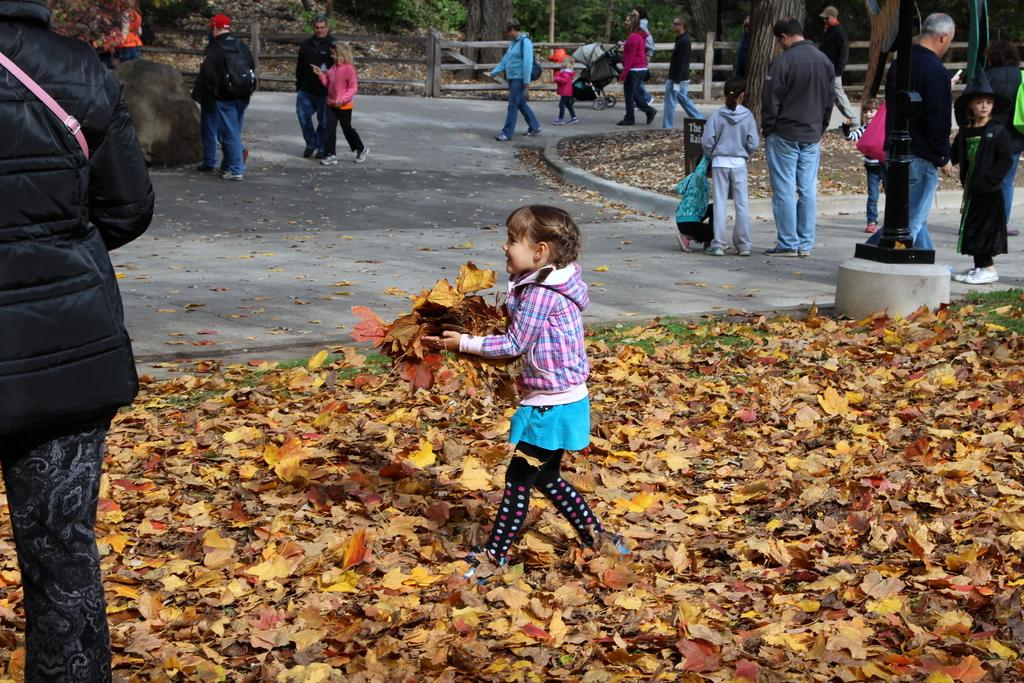What are the people in the image doing? There are people standing and walking in the image. What is the kid holding in the image? The kid is holding leaves in the image. What can be seen at the bottom of the image? There are leaves at the bottom of the image. What is visible in the background of the image? There are trees visible in the background of the image. Is it nighttime in the image, and can you see snow falling? The image does not depict nighttime, nor is there any snow visible. 